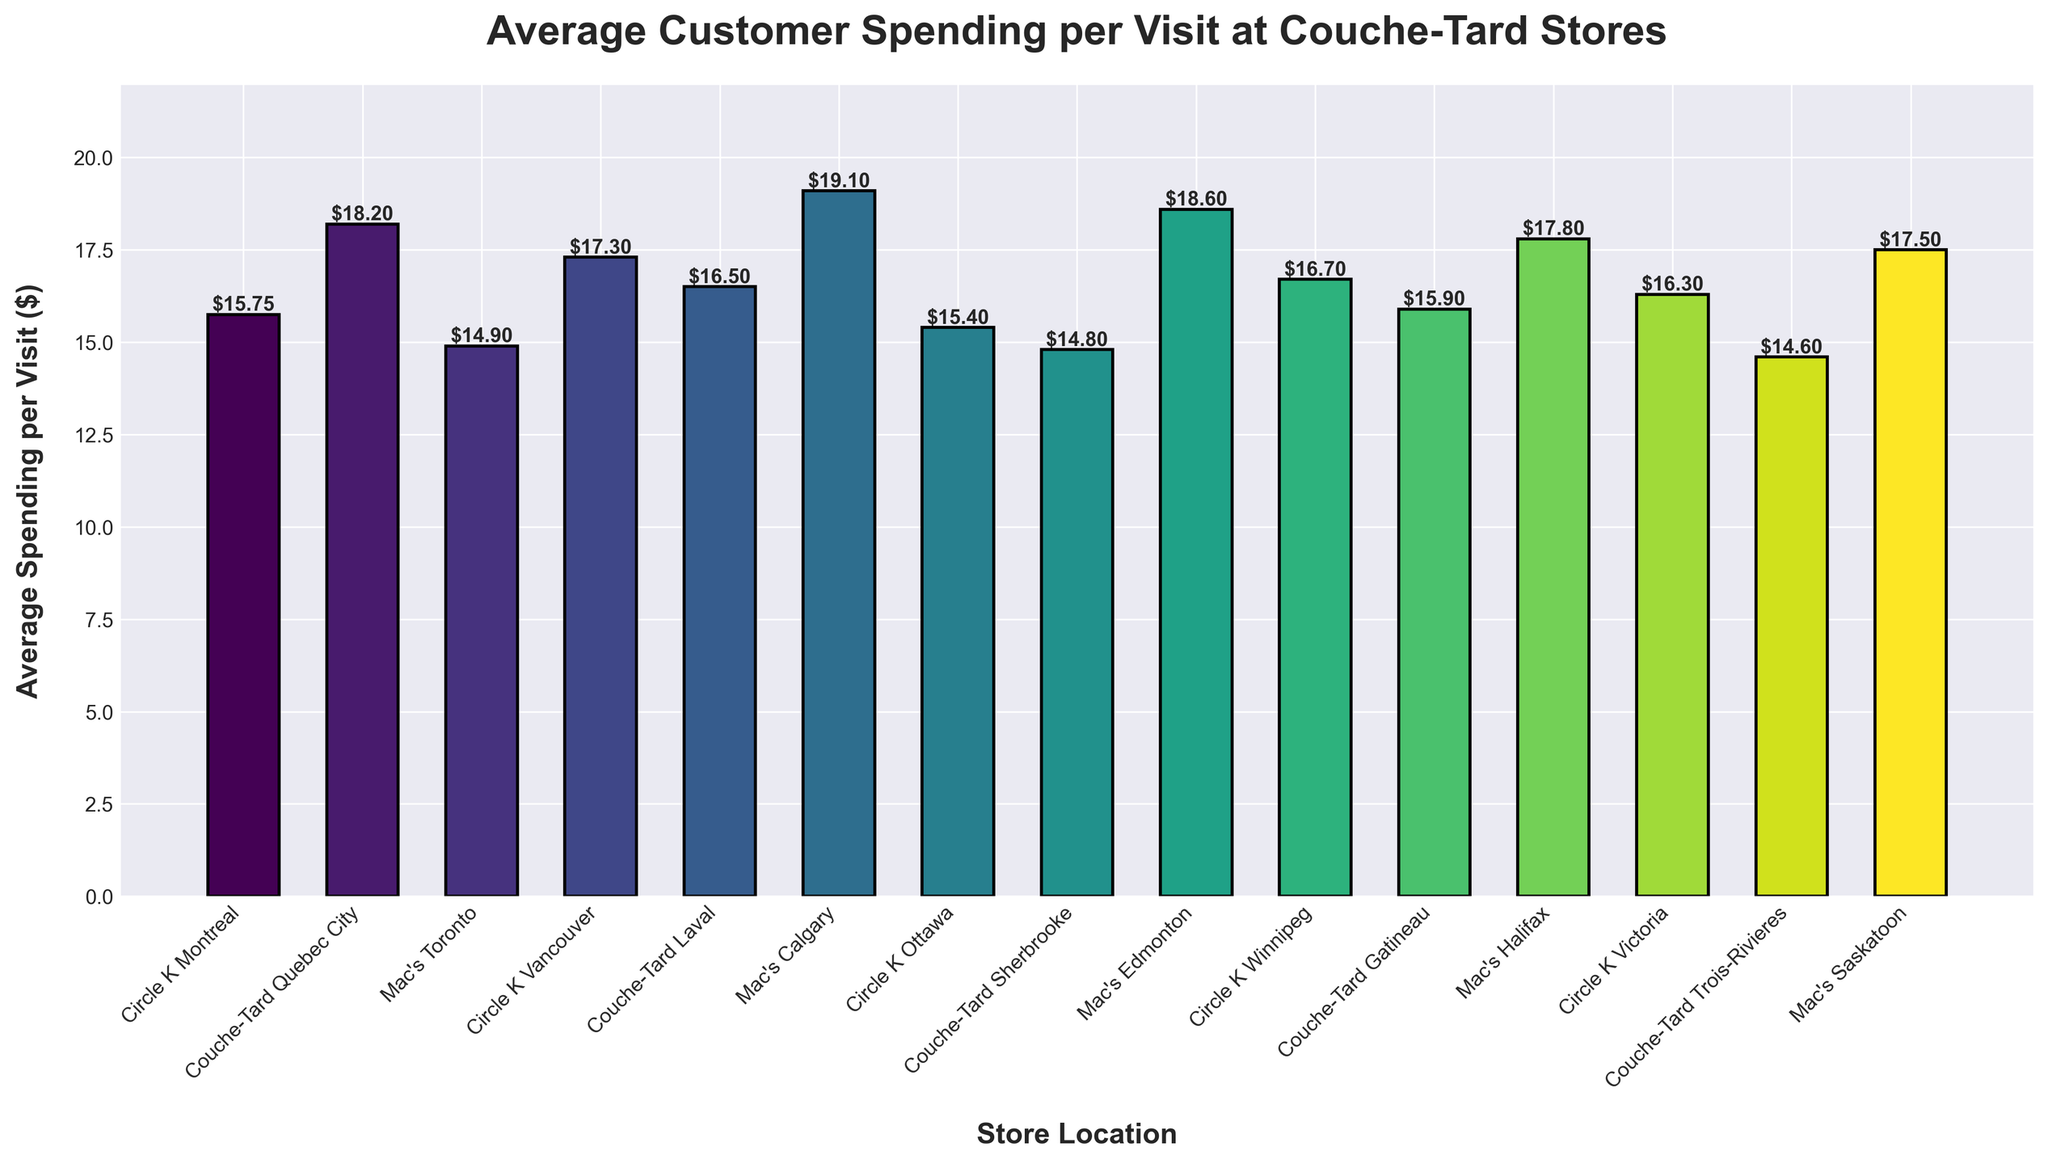Which store location has the highest average spending per visit? Locate the highest bar in the figure, which corresponds to the store location with the highest average spending per visit.
Answer: Mac's Calgary What is the average spending per visit at Circle K Montreal? Find the bar corresponding to Circle K Montreal and read the value at the top of the bar.
Answer: $15.75 How much more does an average customer spend at Mac's Calgary compared to Circle K Montreal? Subtract the spending value of Circle K Montreal from the spending value of Mac's Calgary: $19.10 - $15.75 = $3.35.
Answer: $3.35 Which Circle K store has the lowest average spending per visit? Compare the heights of the bars corresponding to all Circle K locations and identify the smallest one.
Answer: Circle K Ottawa Compare the average spending per visit between Mac's Edmonton and Couche-Tard Sherbrooke. Which one is higher and by how much? Check the heights of the bars for Mac's Edmonton and Couche-Tard Sherbrooke, then subtract the smaller value from the larger value: $18.60 - $14.80 = $3.80.
Answer: Mac's Edmonton, $3.80 What is the combined average spending per visit at Couche-Tard Trois-Rivieres and Mac's Halifax? Sum the spending values of Couche-Tard Trois-Rivieres and Mac's Halifax: $14.60 + $17.80 = $32.40.
Answer: $32.40 What is the difference in average spending per visit between the highest and lowest locations? Identify the highest average spending (Mac's Calgary, $19.10) and the lowest average spending (Couche-Tard Trois-Rivieres, $14.60) and subtract them: $19.10 - $14.60 = $4.50.
Answer: $4.50 How does the average spending at Circle K Vancouver compare to the average spending at Mac's Halifax? Find and compare the values for Circle K Vancouver ($17.30) and Mac's Halifax ($17.80).
Answer: Mac's Halifax is $0.50 higher 